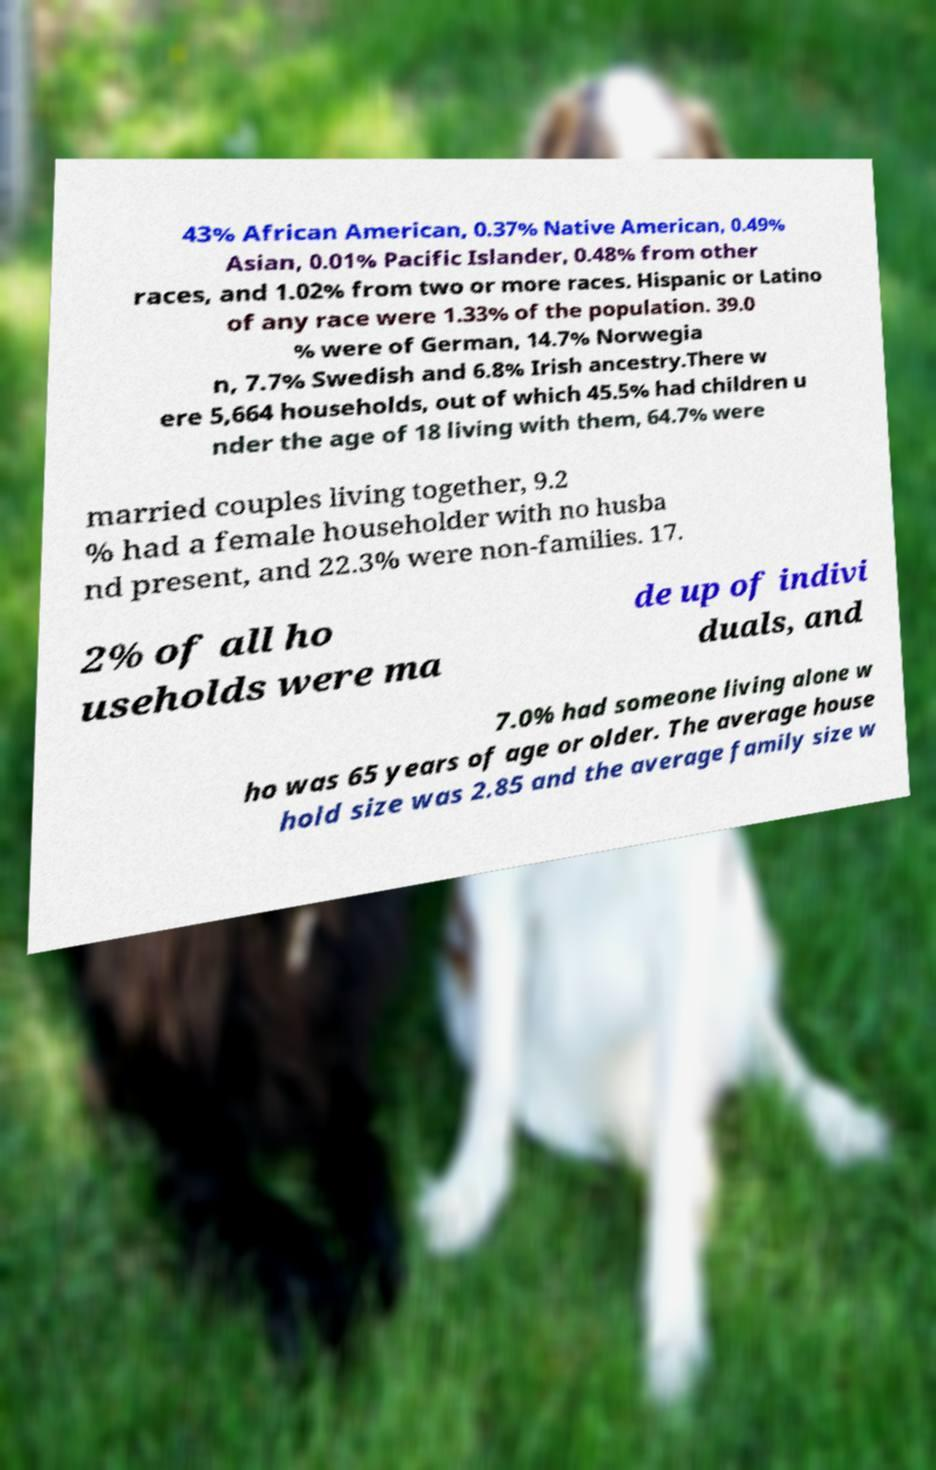For documentation purposes, I need the text within this image transcribed. Could you provide that? 43% African American, 0.37% Native American, 0.49% Asian, 0.01% Pacific Islander, 0.48% from other races, and 1.02% from two or more races. Hispanic or Latino of any race were 1.33% of the population. 39.0 % were of German, 14.7% Norwegia n, 7.7% Swedish and 6.8% Irish ancestry.There w ere 5,664 households, out of which 45.5% had children u nder the age of 18 living with them, 64.7% were married couples living together, 9.2 % had a female householder with no husba nd present, and 22.3% were non-families. 17. 2% of all ho useholds were ma de up of indivi duals, and 7.0% had someone living alone w ho was 65 years of age or older. The average house hold size was 2.85 and the average family size w 